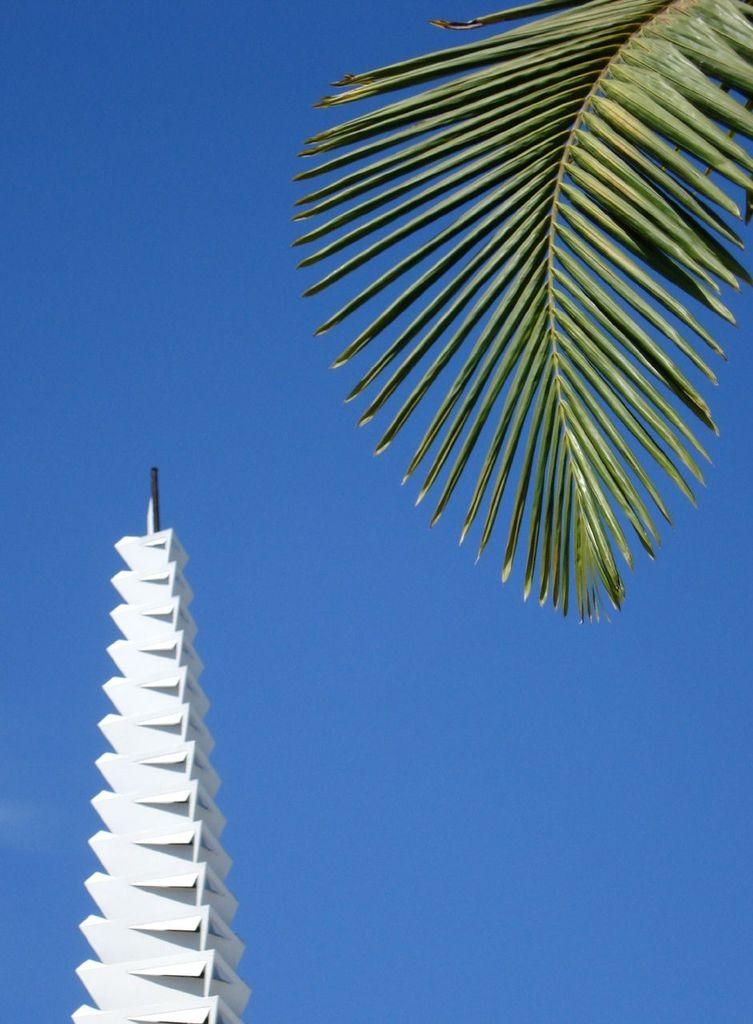What type of plant is featured in the image? There is a coconut tree leaf in the image. What structure can be seen in the image? There is a tower in the image. What is visible in the background of the image? The sky is visible in the background of the image. How many sisters are present in the image? There are no sisters mentioned or depicted in the image. What country is the image taken in? The image does not provide any information about the country where it was taken. 